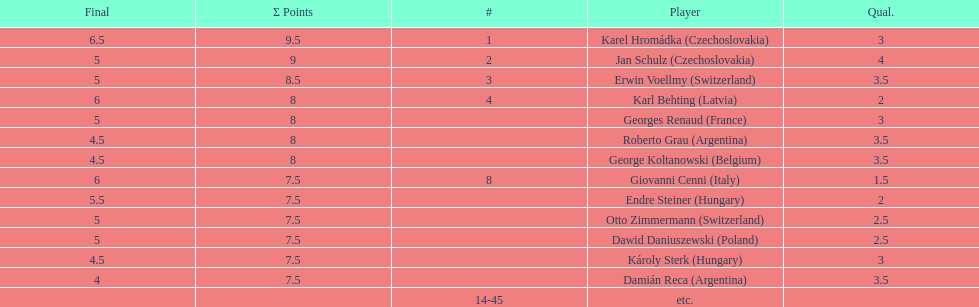How many players had final scores higher than 5? 4. 